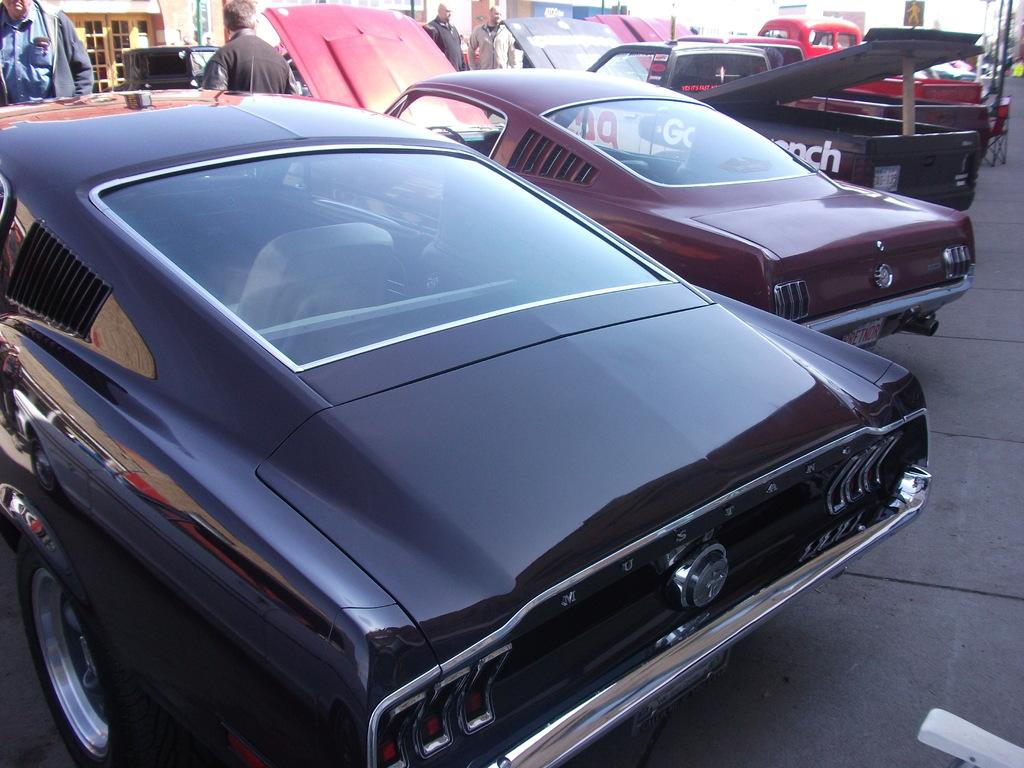What can be seen on the road in the image? There are vehicles on the road in the image. What else can be seen in the background of the image? There are people and some objects visible in the background of the image. Can you hear the bear coughing in the image? There is no bear or coughing sound present in the image. 